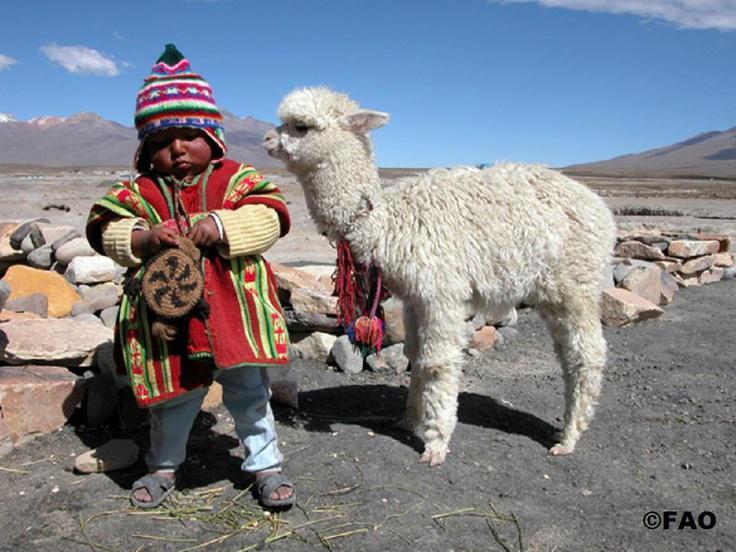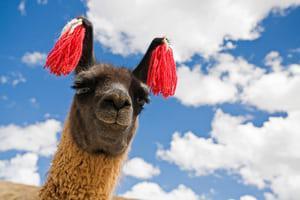The first image is the image on the left, the second image is the image on the right. For the images displayed, is the sentence "an alpaca has tassles dangling from its ears" factually correct? Answer yes or no. Yes. The first image is the image on the left, the second image is the image on the right. Analyze the images presented: Is the assertion "One image shows a single brownish llama with its head angled rightward and red tassles on the ends of its dark upright ears." valid? Answer yes or no. Yes. 